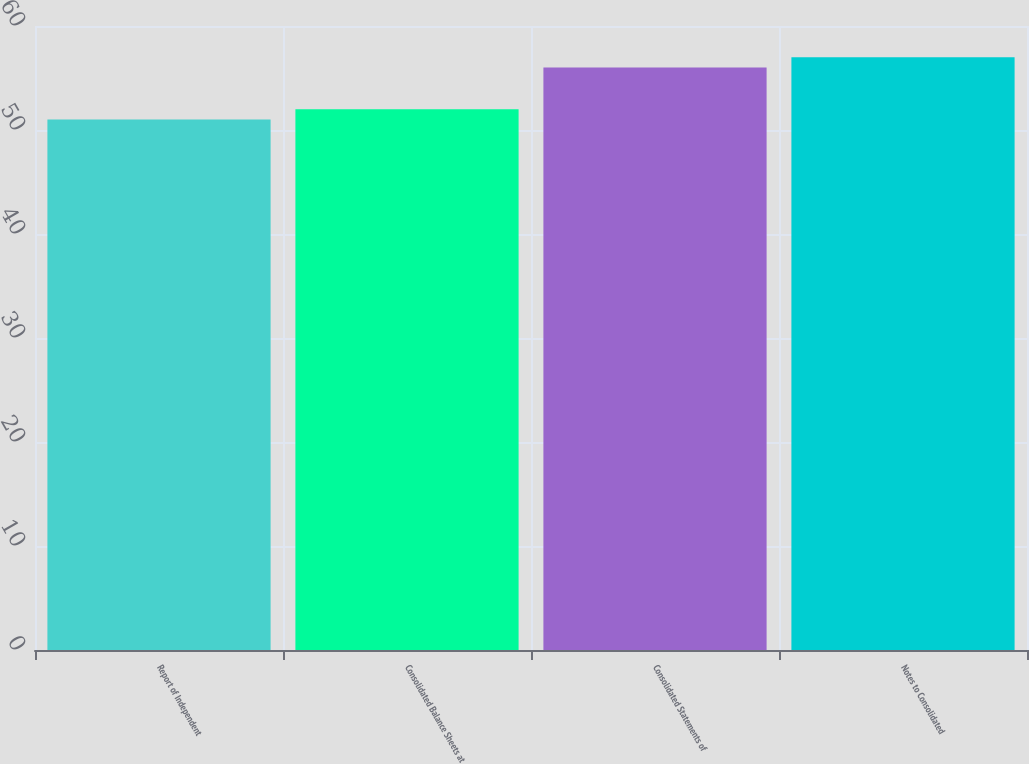Convert chart to OTSL. <chart><loc_0><loc_0><loc_500><loc_500><bar_chart><fcel>Report of Independent<fcel>Consolidated Balance Sheets at<fcel>Consolidated Statements of<fcel>Notes to Consolidated<nl><fcel>51<fcel>52<fcel>56<fcel>57<nl></chart> 